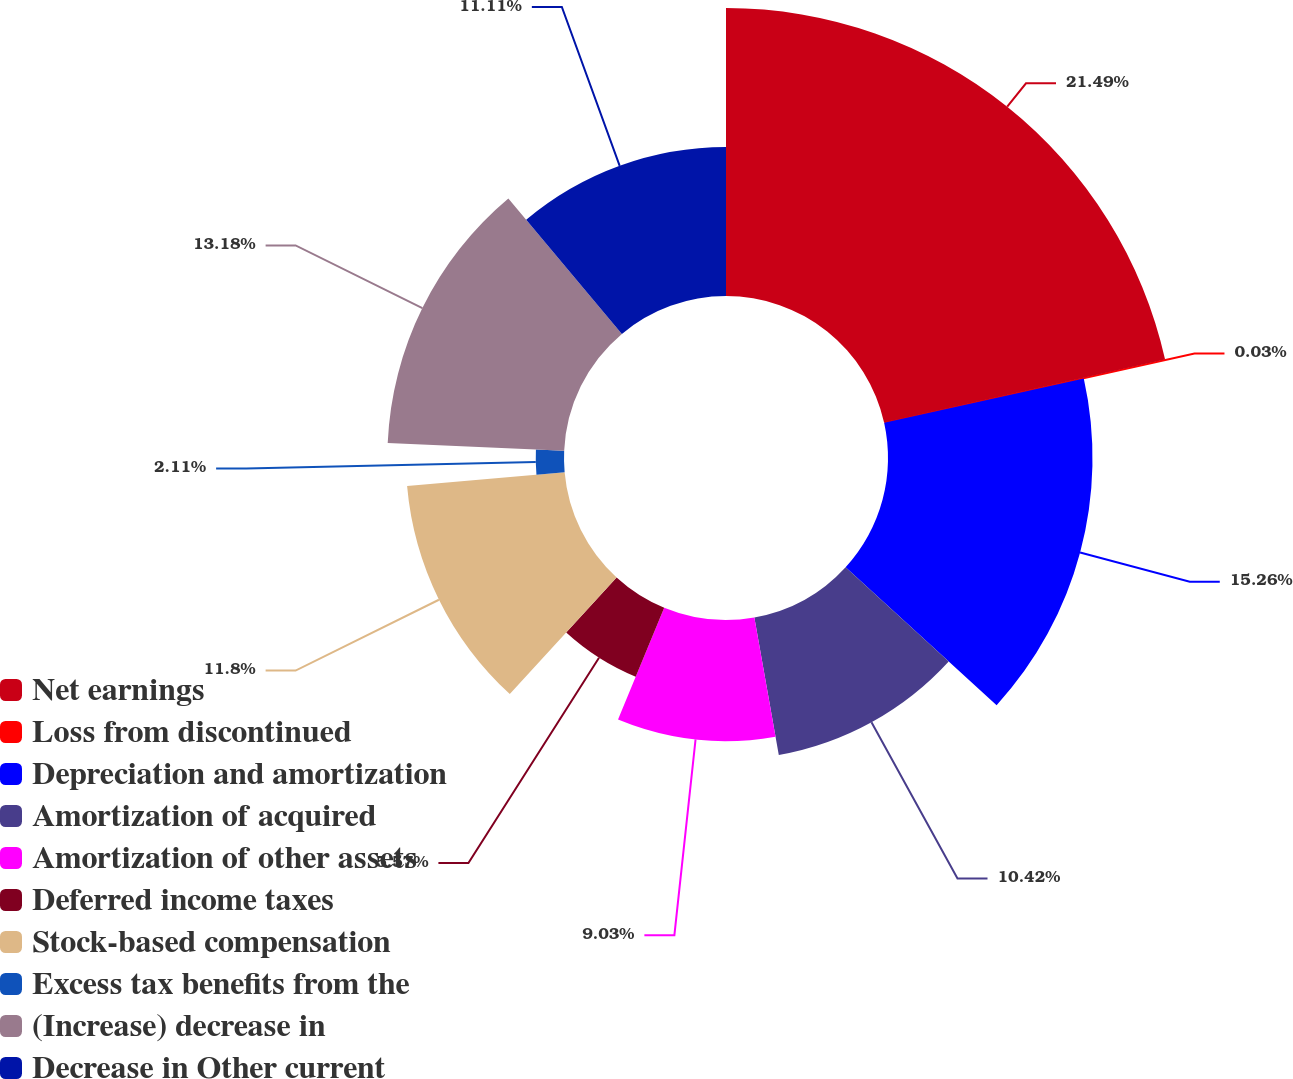<chart> <loc_0><loc_0><loc_500><loc_500><pie_chart><fcel>Net earnings<fcel>Loss from discontinued<fcel>Depreciation and amortization<fcel>Amortization of acquired<fcel>Amortization of other assets<fcel>Deferred income taxes<fcel>Stock-based compensation<fcel>Excess tax benefits from the<fcel>(Increase) decrease in<fcel>Decrease in Other current<nl><fcel>21.49%<fcel>0.03%<fcel>15.26%<fcel>10.42%<fcel>9.03%<fcel>5.57%<fcel>11.8%<fcel>2.11%<fcel>13.18%<fcel>11.11%<nl></chart> 